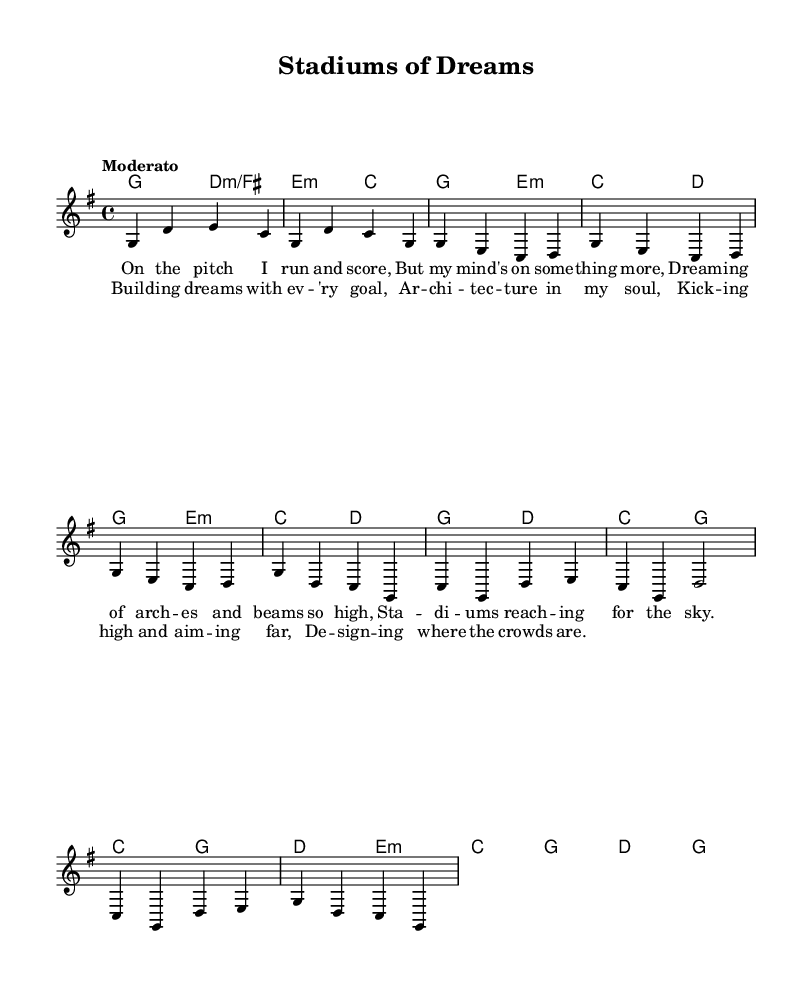What is the key signature of this music? The key signature is G major, which has one sharp, F#. This can be identified from the global settings at the beginning of the sheet music.
Answer: G major What is the time signature of this music? The time signature is 4/4, indicating that there are four beats in each measure. This is specified in the global settings as well.
Answer: 4/4 What is the tempo marking of this music? The tempo marking is "Moderato," suggesting a moderate pace for the performance. This is noted in the global settings of the sheet music.
Answer: Moderato How many measures are in the chorus? The chorus consists of four measures. By counting the measures in the chorus section of the sheet music, you can verify this.
Answer: 4 What is the first lyric of the verse? The first lyric is "On the pitch I run and score," which is evident in the lyrics section of the music directly under the melody notes.
Answer: On the pitch I run and score What architectural themes are present in the lyrics? The themes include "arches" and "beams," which reflect aspirations in architectural design. These themes can be found in the context of the verse lyrics.
Answer: Arches and beams What sport is referenced in the music? The sport referenced is soccer, as indicated by phrases like "run and score" from the lyrics that describe actions associated with soccer.
Answer: Soccer 